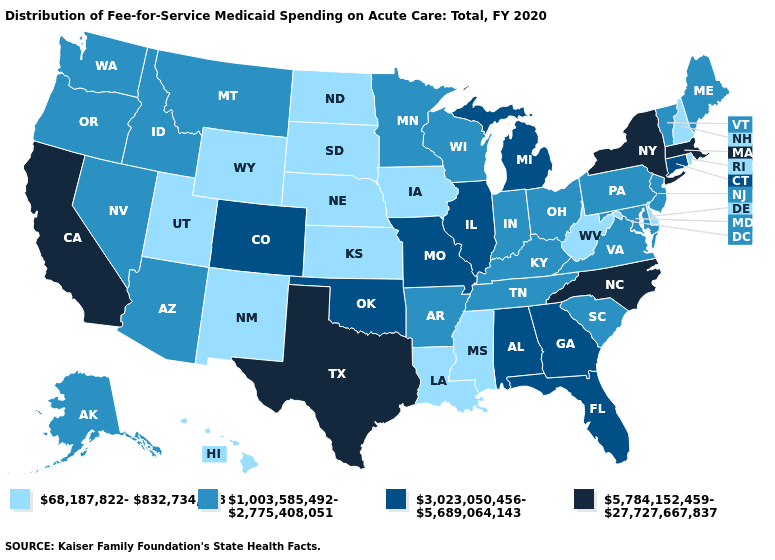Among the states that border Nevada , which have the lowest value?
Concise answer only. Utah. What is the lowest value in the USA?
Quick response, please. 68,187,822-832,734,728. Among the states that border Montana , which have the highest value?
Quick response, please. Idaho. Does the map have missing data?
Quick response, please. No. What is the value of North Carolina?
Short answer required. 5,784,152,459-27,727,667,837. Among the states that border New York , which have the lowest value?
Short answer required. New Jersey, Pennsylvania, Vermont. Does Montana have a higher value than South Dakota?
Write a very short answer. Yes. Among the states that border Indiana , which have the highest value?
Give a very brief answer. Illinois, Michigan. Name the states that have a value in the range 1,003,585,492-2,775,408,051?
Quick response, please. Alaska, Arizona, Arkansas, Idaho, Indiana, Kentucky, Maine, Maryland, Minnesota, Montana, Nevada, New Jersey, Ohio, Oregon, Pennsylvania, South Carolina, Tennessee, Vermont, Virginia, Washington, Wisconsin. Among the states that border Delaware , which have the highest value?
Quick response, please. Maryland, New Jersey, Pennsylvania. Name the states that have a value in the range 68,187,822-832,734,728?
Keep it brief. Delaware, Hawaii, Iowa, Kansas, Louisiana, Mississippi, Nebraska, New Hampshire, New Mexico, North Dakota, Rhode Island, South Dakota, Utah, West Virginia, Wyoming. Name the states that have a value in the range 68,187,822-832,734,728?
Be succinct. Delaware, Hawaii, Iowa, Kansas, Louisiana, Mississippi, Nebraska, New Hampshire, New Mexico, North Dakota, Rhode Island, South Dakota, Utah, West Virginia, Wyoming. What is the value of Massachusetts?
Keep it brief. 5,784,152,459-27,727,667,837. Does Texas have the lowest value in the USA?
Short answer required. No. Does Kansas have the lowest value in the MidWest?
Quick response, please. Yes. 